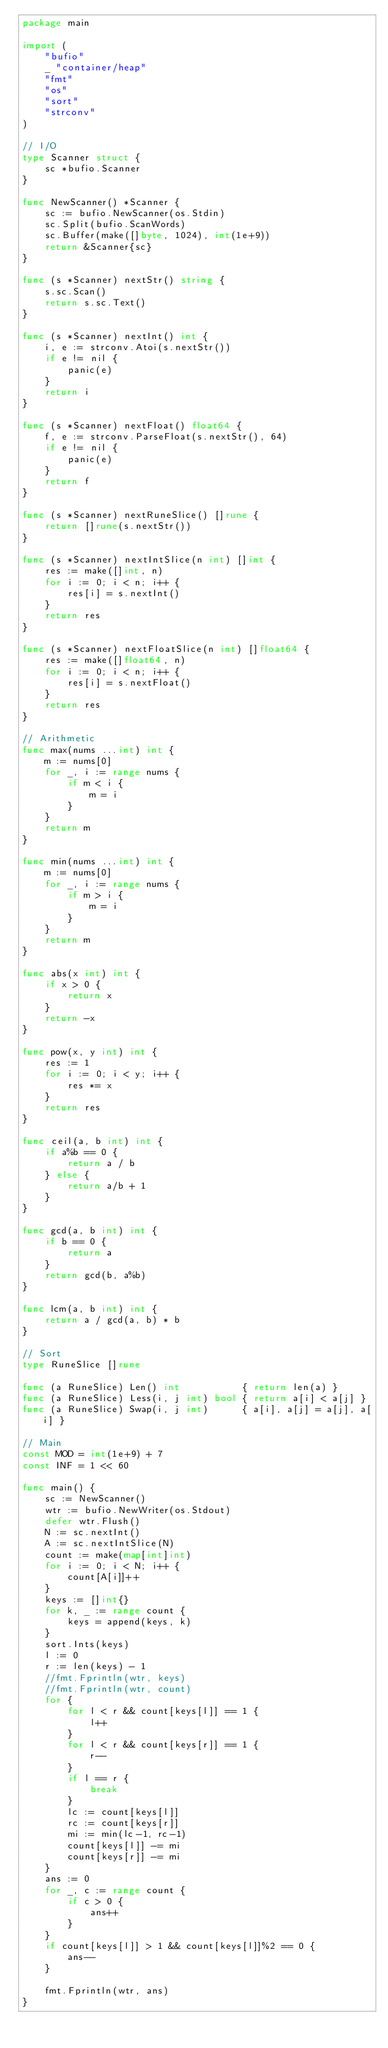<code> <loc_0><loc_0><loc_500><loc_500><_Go_>package main

import (
	"bufio"
	_ "container/heap"
	"fmt"
	"os"
	"sort"
	"strconv"
)

// I/O
type Scanner struct {
	sc *bufio.Scanner
}

func NewScanner() *Scanner {
	sc := bufio.NewScanner(os.Stdin)
	sc.Split(bufio.ScanWords)
	sc.Buffer(make([]byte, 1024), int(1e+9))
	return &Scanner{sc}
}

func (s *Scanner) nextStr() string {
	s.sc.Scan()
	return s.sc.Text()
}

func (s *Scanner) nextInt() int {
	i, e := strconv.Atoi(s.nextStr())
	if e != nil {
		panic(e)
	}
	return i
}

func (s *Scanner) nextFloat() float64 {
	f, e := strconv.ParseFloat(s.nextStr(), 64)
	if e != nil {
		panic(e)
	}
	return f
}

func (s *Scanner) nextRuneSlice() []rune {
	return []rune(s.nextStr())
}

func (s *Scanner) nextIntSlice(n int) []int {
	res := make([]int, n)
	for i := 0; i < n; i++ {
		res[i] = s.nextInt()
	}
	return res
}

func (s *Scanner) nextFloatSlice(n int) []float64 {
	res := make([]float64, n)
	for i := 0; i < n; i++ {
		res[i] = s.nextFloat()
	}
	return res
}

// Arithmetic
func max(nums ...int) int {
	m := nums[0]
	for _, i := range nums {
		if m < i {
			m = i
		}
	}
	return m
}

func min(nums ...int) int {
	m := nums[0]
	for _, i := range nums {
		if m > i {
			m = i
		}
	}
	return m
}

func abs(x int) int {
	if x > 0 {
		return x
	}
	return -x
}

func pow(x, y int) int {
	res := 1
	for i := 0; i < y; i++ {
		res *= x
	}
	return res
}

func ceil(a, b int) int {
	if a%b == 0 {
		return a / b
	} else {
		return a/b + 1
	}
}

func gcd(a, b int) int {
	if b == 0 {
		return a
	}
	return gcd(b, a%b)
}

func lcm(a, b int) int {
	return a / gcd(a, b) * b
}

// Sort
type RuneSlice []rune

func (a RuneSlice) Len() int           { return len(a) }
func (a RuneSlice) Less(i, j int) bool { return a[i] < a[j] }
func (a RuneSlice) Swap(i, j int)      { a[i], a[j] = a[j], a[i] }

// Main
const MOD = int(1e+9) + 7
const INF = 1 << 60

func main() {
	sc := NewScanner()
	wtr := bufio.NewWriter(os.Stdout)
	defer wtr.Flush()
	N := sc.nextInt()
	A := sc.nextIntSlice(N)
	count := make(map[int]int)
	for i := 0; i < N; i++ {
		count[A[i]]++
	}
	keys := []int{}
	for k, _ := range count {
		keys = append(keys, k)
	}
	sort.Ints(keys)
	l := 0
	r := len(keys) - 1
	//fmt.Fprintln(wtr, keys)
	//fmt.Fprintln(wtr, count)
	for {
		for l < r && count[keys[l]] == 1 {
			l++
		}
		for l < r && count[keys[r]] == 1 {
			r--
		}
		if l == r {
			break
		}
		lc := count[keys[l]]
		rc := count[keys[r]]
		mi := min(lc-1, rc-1)
		count[keys[l]] -= mi
		count[keys[r]] -= mi
	}
	ans := 0
	for _, c := range count {
		if c > 0 {
			ans++
		}
	}
	if count[keys[l]] > 1 && count[keys[l]]%2 == 0 {
		ans--
	}

	fmt.Fprintln(wtr, ans)
}
</code> 